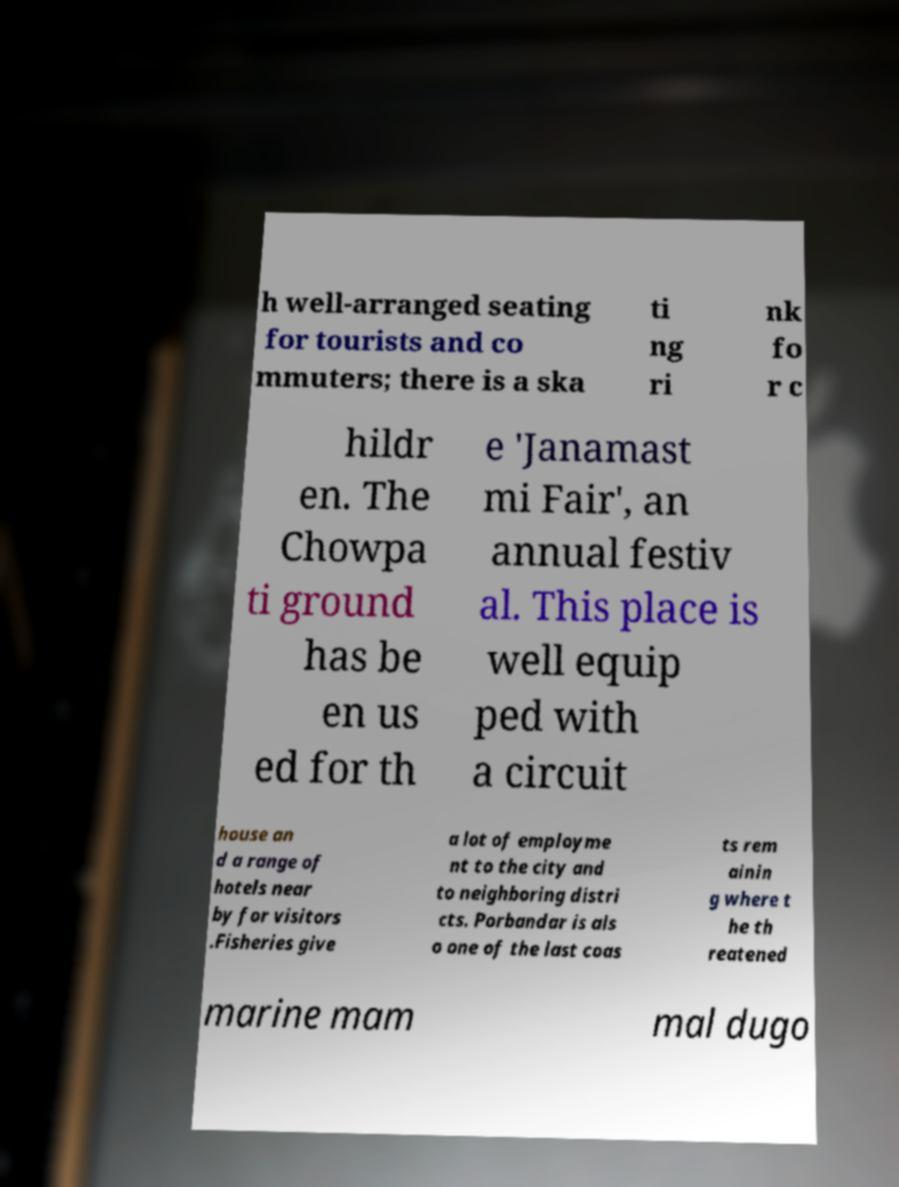Can you read and provide the text displayed in the image?This photo seems to have some interesting text. Can you extract and type it out for me? h well-arranged seating for tourists and co mmuters; there is a ska ti ng ri nk fo r c hildr en. The Chowpa ti ground has be en us ed for th e 'Janamast mi Fair', an annual festiv al. This place is well equip ped with a circuit house an d a range of hotels near by for visitors .Fisheries give a lot of employme nt to the city and to neighboring distri cts. Porbandar is als o one of the last coas ts rem ainin g where t he th reatened marine mam mal dugo 